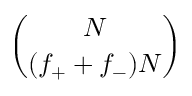<formula> <loc_0><loc_0><loc_500><loc_500>\binom { N } { ( f _ { + } + f _ { - } ) N }</formula> 